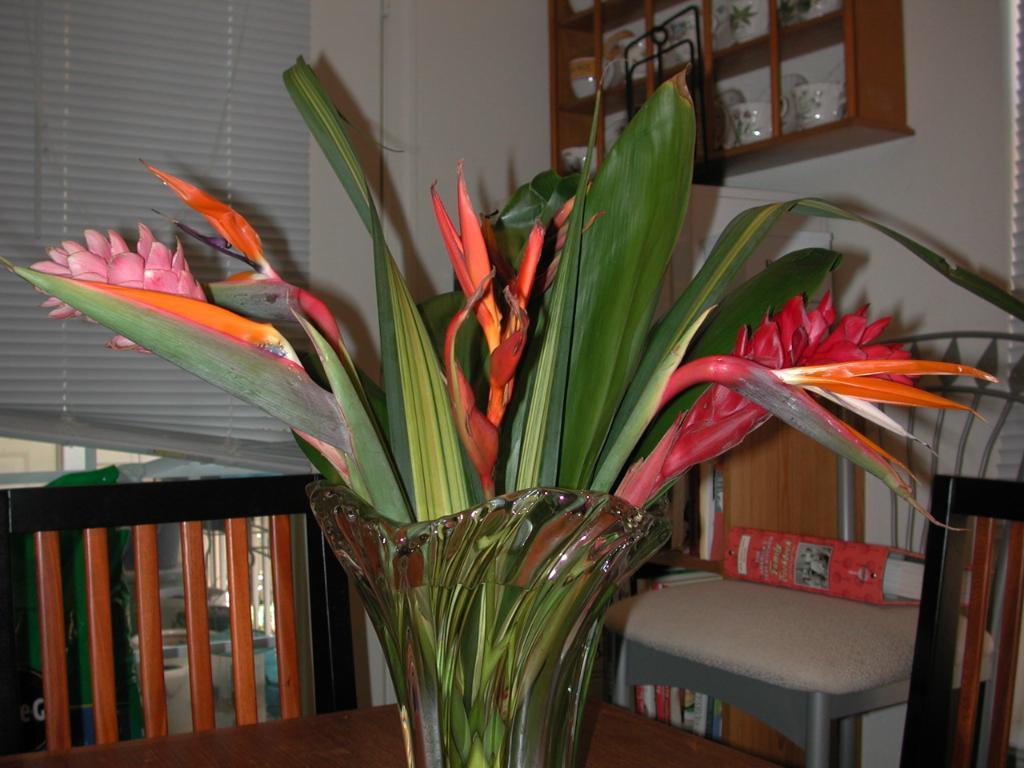In one or two sentences, can you explain what this image depicts? In this image we can see a flower vase is kept on the wooden table. Here we can see chairs, a file kept on the chair, wooden cupboard in which cups are kept and the window blinds in the background. 